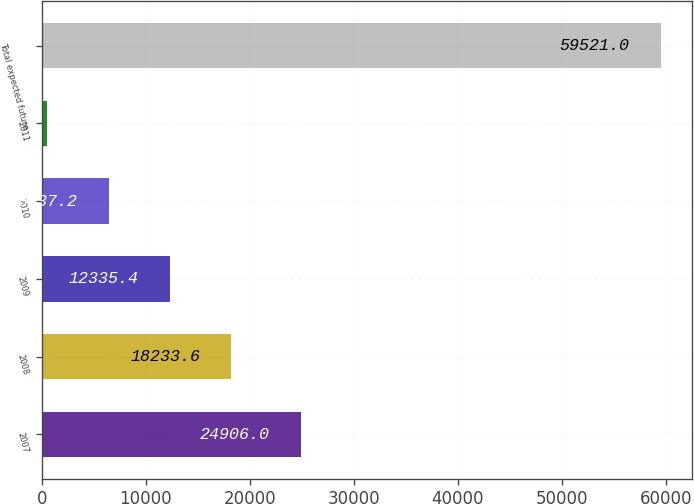Convert chart. <chart><loc_0><loc_0><loc_500><loc_500><bar_chart><fcel>2007<fcel>2008<fcel>2009<fcel>2010<fcel>2011<fcel>Total expected future<nl><fcel>24906<fcel>18233.6<fcel>12335.4<fcel>6437.2<fcel>539<fcel>59521<nl></chart> 